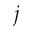<formula> <loc_0><loc_0><loc_500><loc_500>j</formula> 